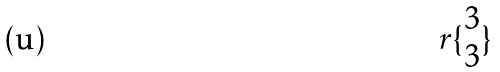Convert formula to latex. <formula><loc_0><loc_0><loc_500><loc_500>r \{ \begin{matrix} 3 \\ 3 \end{matrix} \}</formula> 